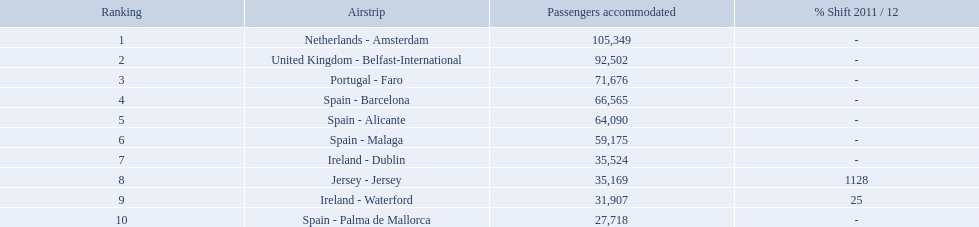Which airports had passengers going through london southend airport? Netherlands - Amsterdam, United Kingdom - Belfast-International, Portugal - Faro, Spain - Barcelona, Spain - Alicante, Spain - Malaga, Ireland - Dublin, Jersey - Jersey, Ireland - Waterford, Spain - Palma de Mallorca. Of those airports, which airport had the least amount of passengers going through london southend airport? Spain - Palma de Mallorca. What are all of the airports? Netherlands - Amsterdam, United Kingdom - Belfast-International, Portugal - Faro, Spain - Barcelona, Spain - Alicante, Spain - Malaga, Ireland - Dublin, Jersey - Jersey, Ireland - Waterford, Spain - Palma de Mallorca. How many passengers have they handled? 105,349, 92,502, 71,676, 66,565, 64,090, 59,175, 35,524, 35,169, 31,907, 27,718. And which airport has handled the most passengers? Netherlands - Amsterdam. What are the 10 busiest routes to and from london southend airport? Netherlands - Amsterdam, United Kingdom - Belfast-International, Portugal - Faro, Spain - Barcelona, Spain - Alicante, Spain - Malaga, Ireland - Dublin, Jersey - Jersey, Ireland - Waterford, Spain - Palma de Mallorca. Of these, which airport is in portugal? Portugal - Faro. What is the highest number of passengers handled? 105,349. What is the destination of the passengers leaving the area that handles 105,349 travellers? Netherlands - Amsterdam. 